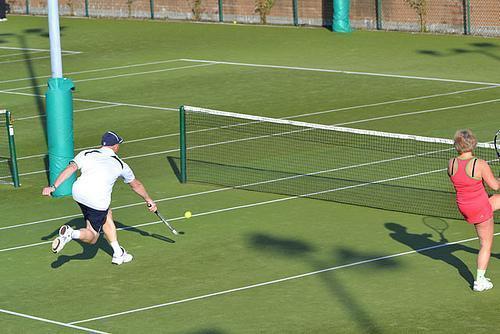How many people are in the photo?
Give a very brief answer. 2. 